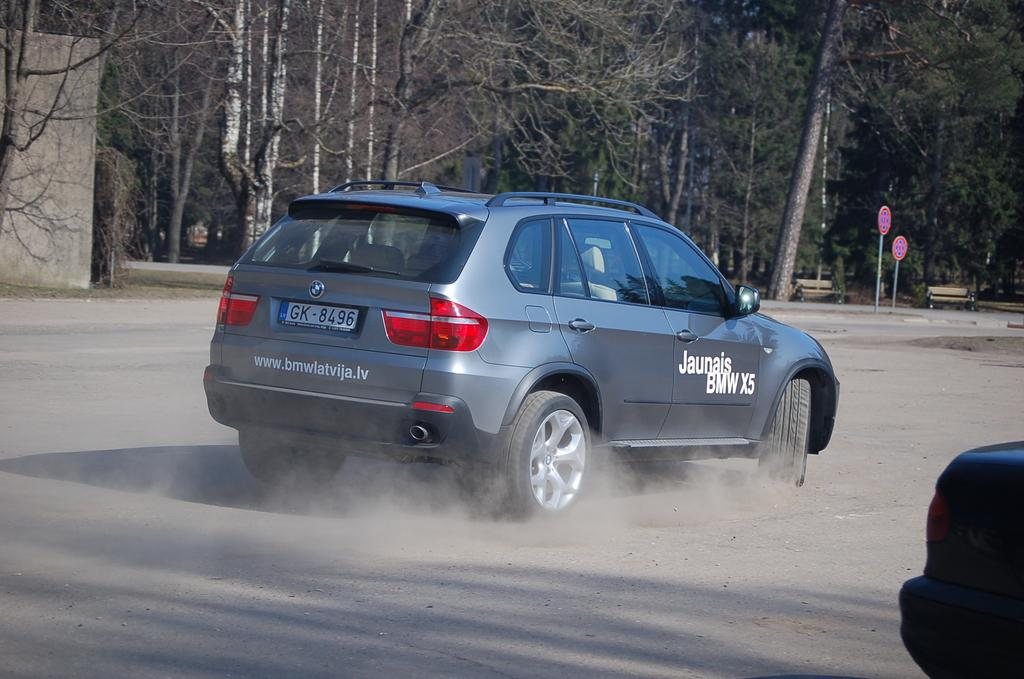<image>
Share a concise interpretation of the image provided. A blue crossover SUV that says Jaunais BMW X 5 